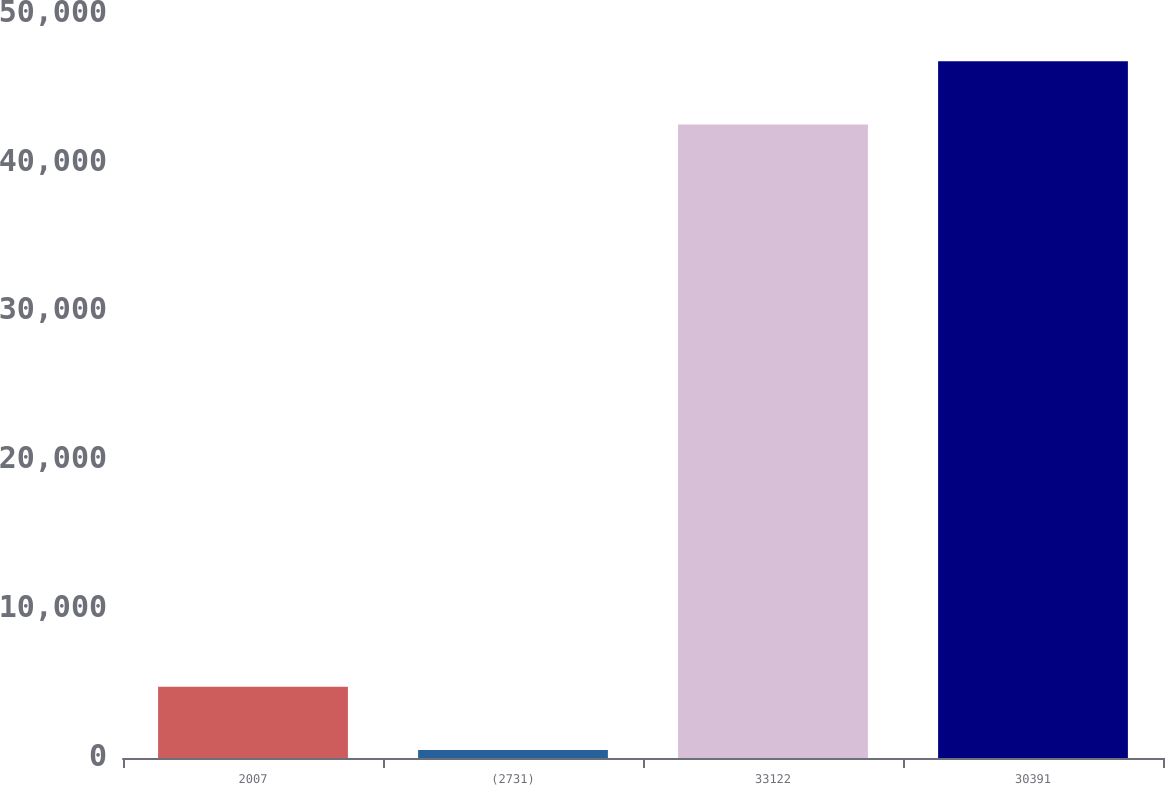Convert chart. <chart><loc_0><loc_0><loc_500><loc_500><bar_chart><fcel>2007<fcel>(2731)<fcel>33122<fcel>30391<nl><fcel>4787.9<fcel>531<fcel>42569<fcel>46825.9<nl></chart> 